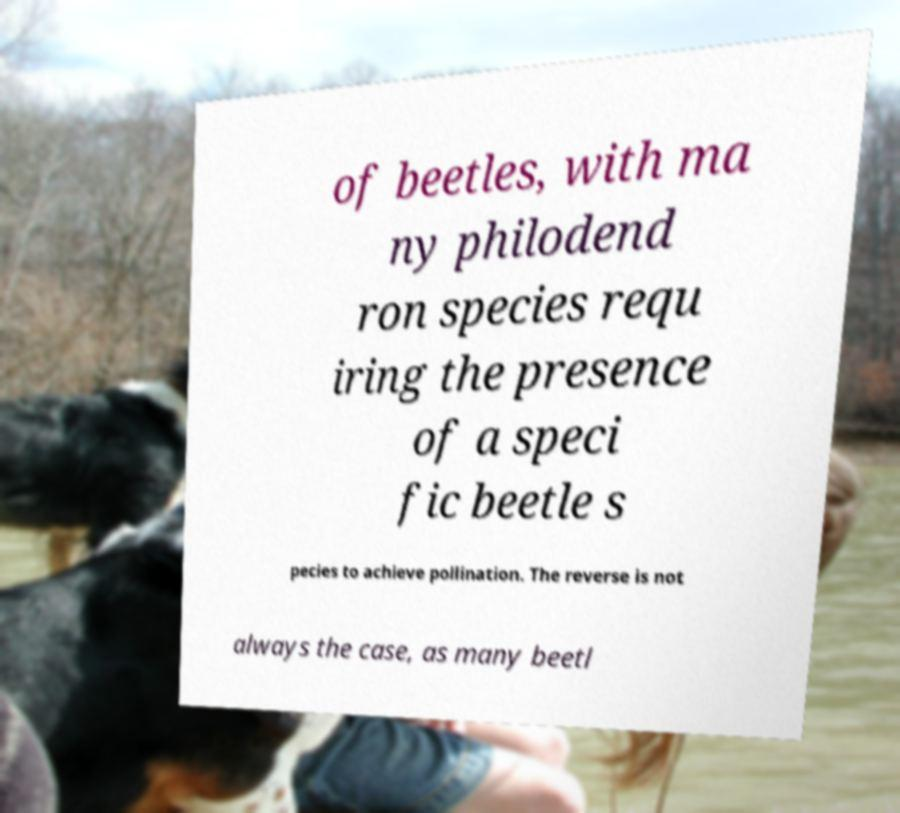For documentation purposes, I need the text within this image transcribed. Could you provide that? of beetles, with ma ny philodend ron species requ iring the presence of a speci fic beetle s pecies to achieve pollination. The reverse is not always the case, as many beetl 